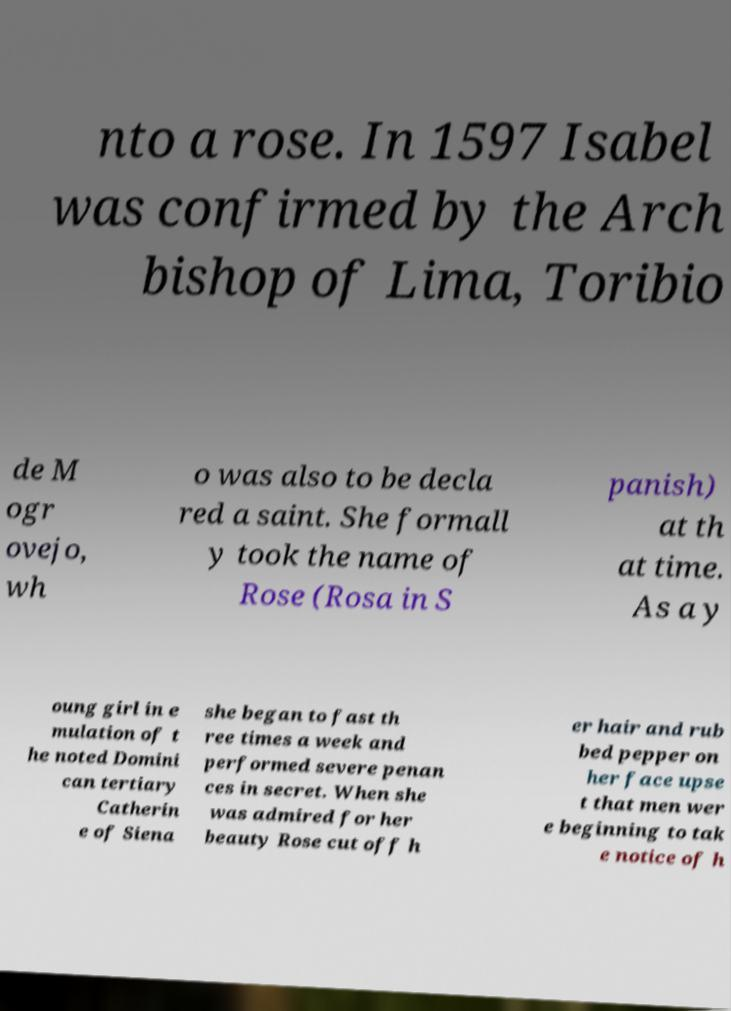Can you read and provide the text displayed in the image?This photo seems to have some interesting text. Can you extract and type it out for me? nto a rose. In 1597 Isabel was confirmed by the Arch bishop of Lima, Toribio de M ogr ovejo, wh o was also to be decla red a saint. She formall y took the name of Rose (Rosa in S panish) at th at time. As a y oung girl in e mulation of t he noted Domini can tertiary Catherin e of Siena she began to fast th ree times a week and performed severe penan ces in secret. When she was admired for her beauty Rose cut off h er hair and rub bed pepper on her face upse t that men wer e beginning to tak e notice of h 